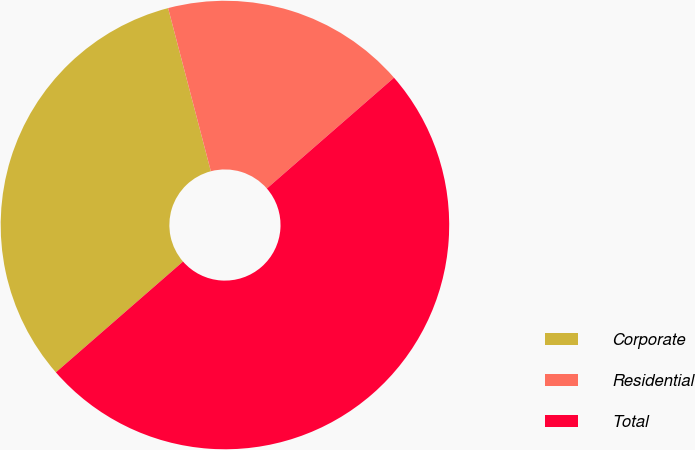<chart> <loc_0><loc_0><loc_500><loc_500><pie_chart><fcel>Corporate<fcel>Residential<fcel>Total<nl><fcel>32.33%<fcel>17.67%<fcel>50.0%<nl></chart> 